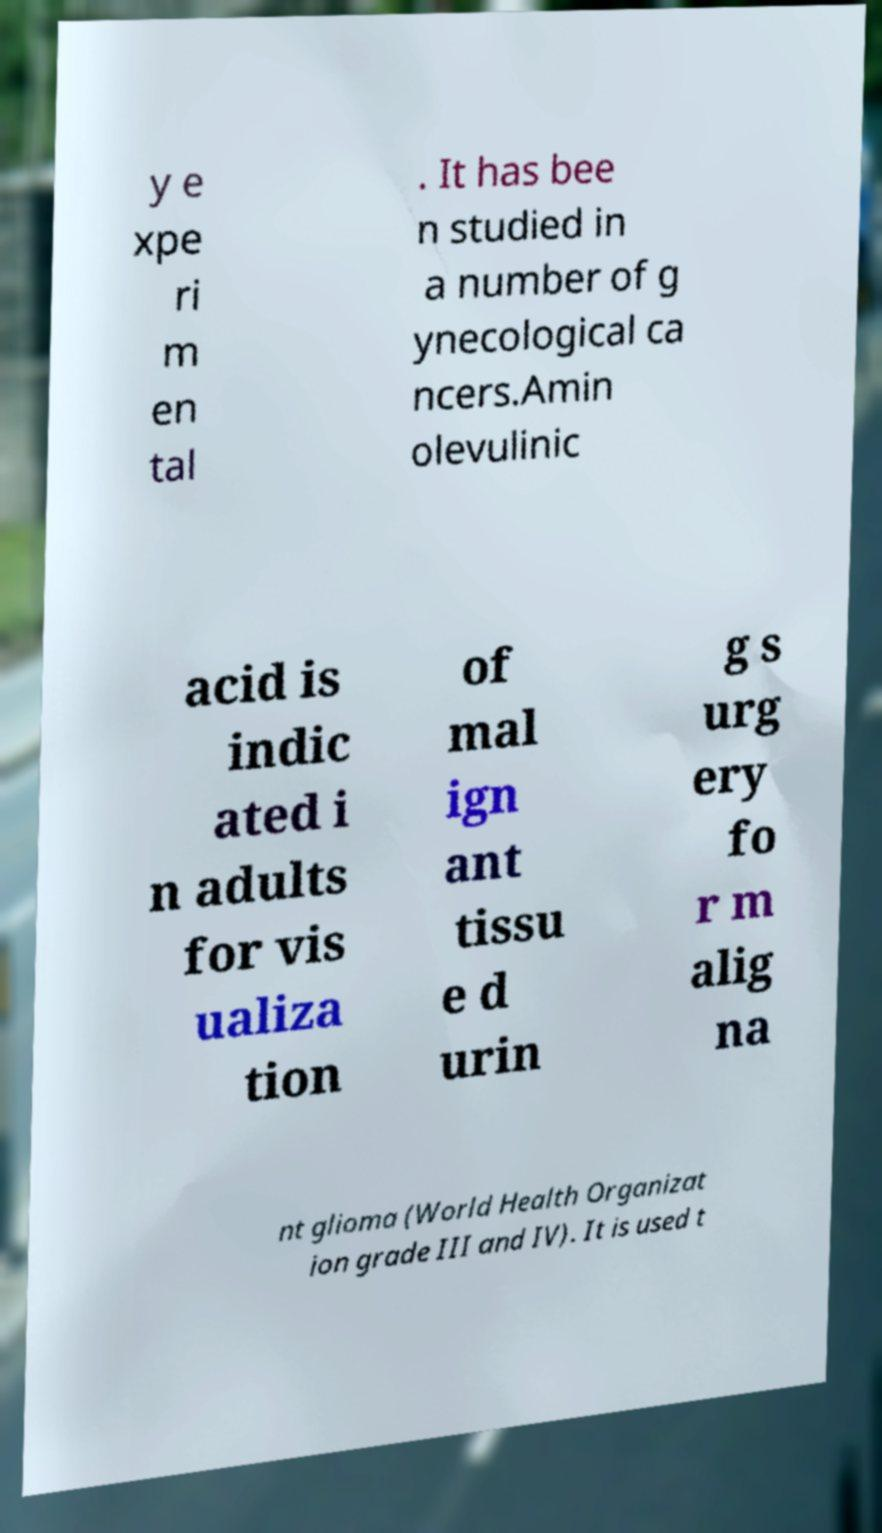What messages or text are displayed in this image? I need them in a readable, typed format. y e xpe ri m en tal . It has bee n studied in a number of g ynecological ca ncers.Amin olevulinic acid is indic ated i n adults for vis ualiza tion of mal ign ant tissu e d urin g s urg ery fo r m alig na nt glioma (World Health Organizat ion grade III and IV). It is used t 